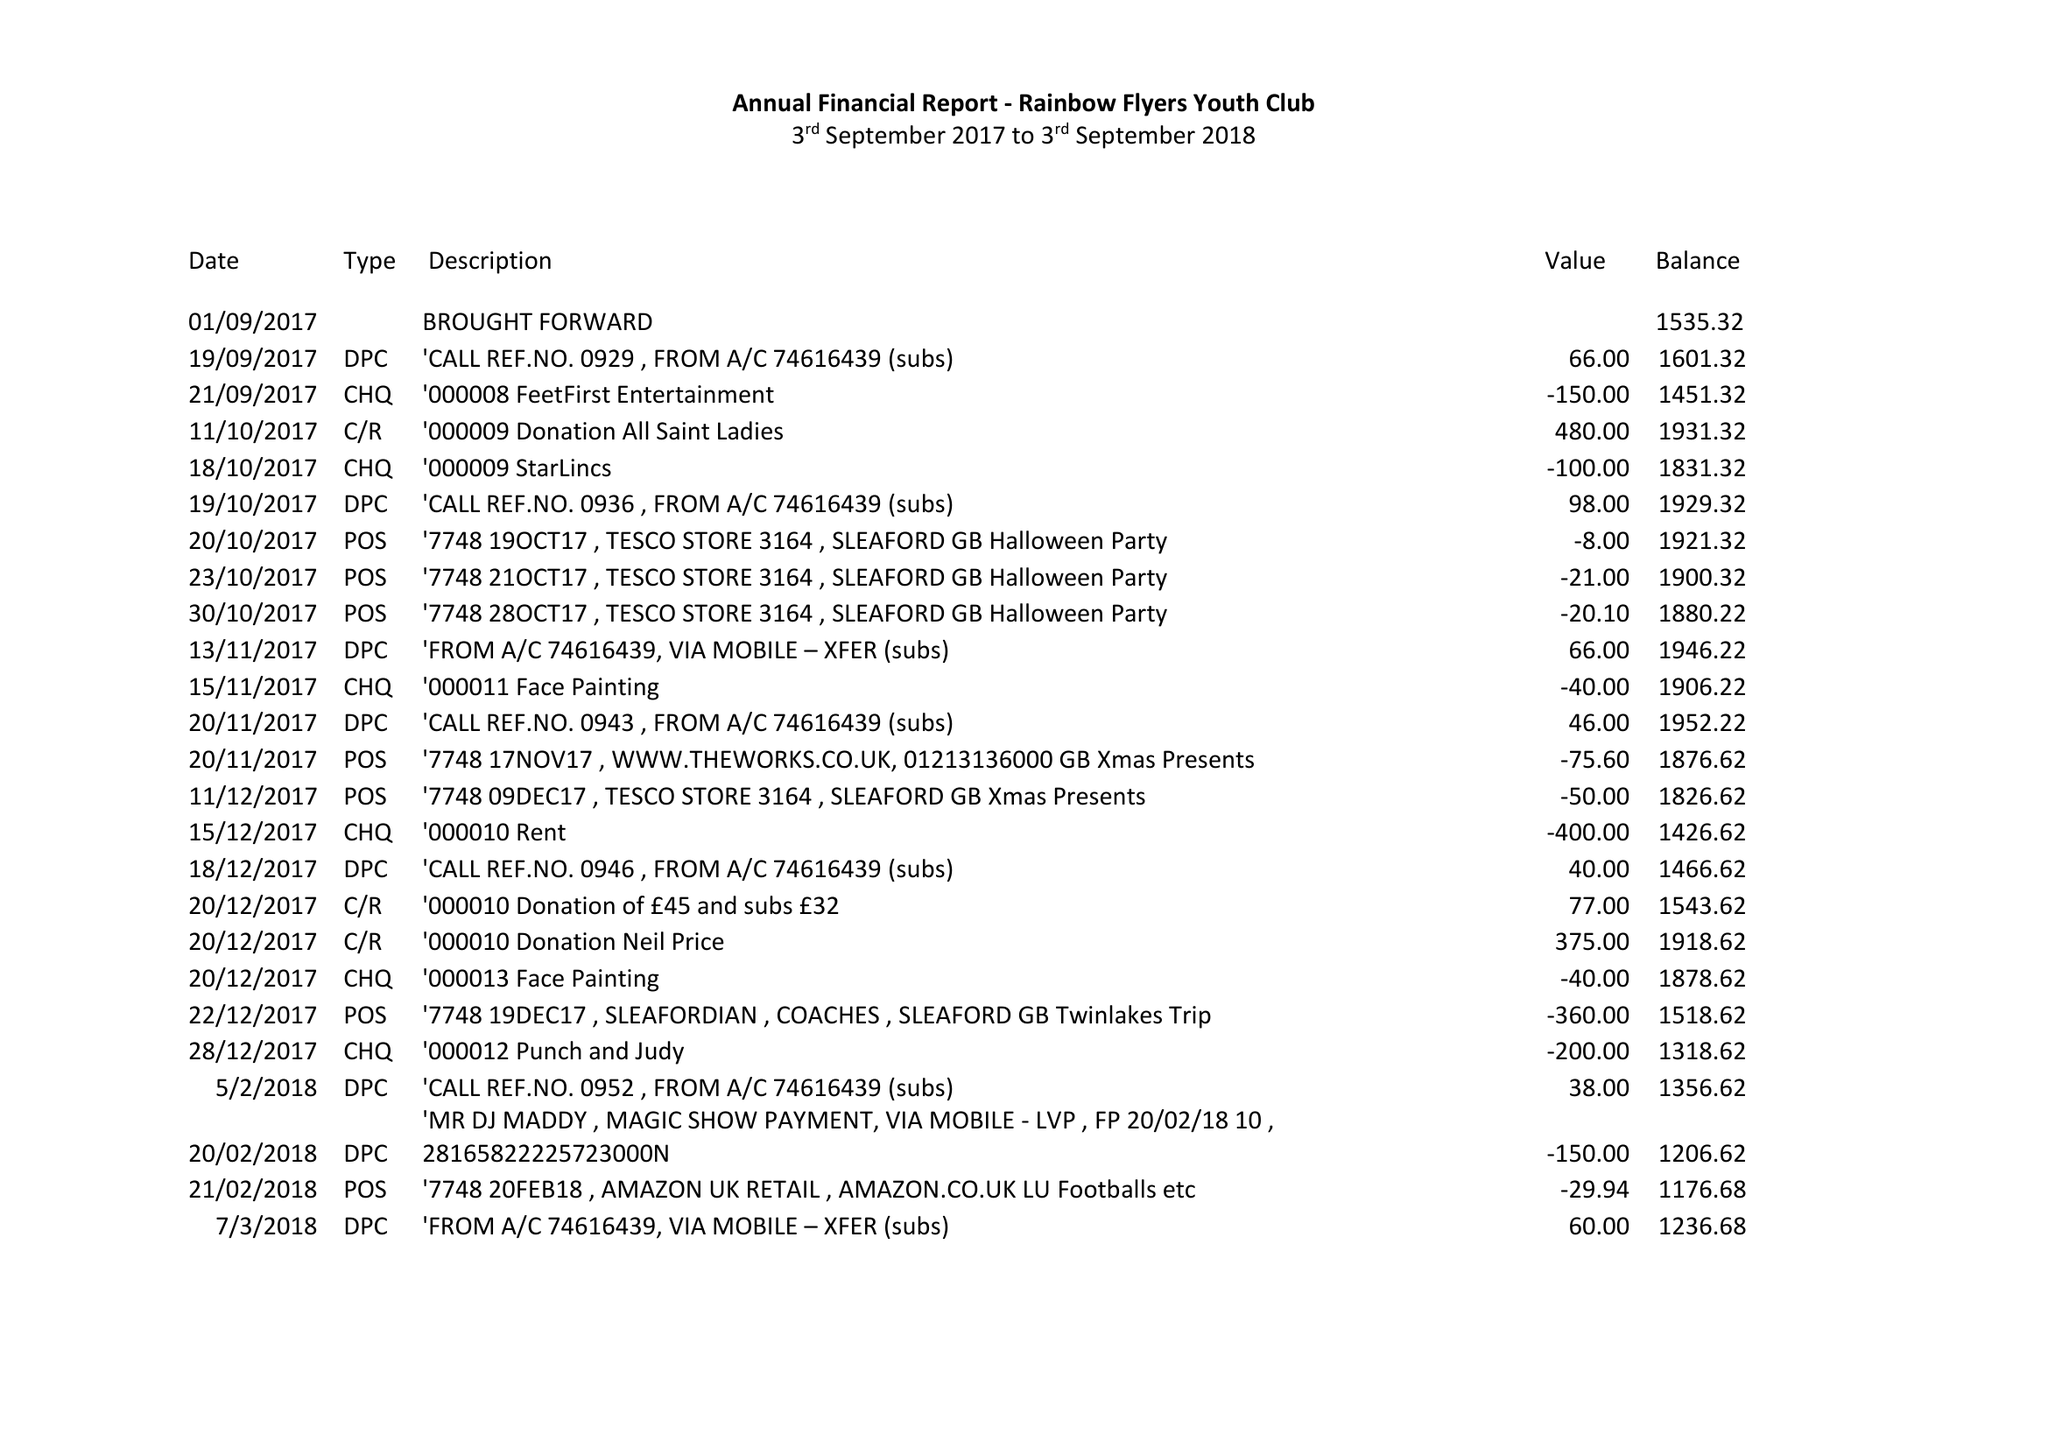What is the value for the address__street_line?
Answer the question using a single word or phrase. 50 HIGH STREET 